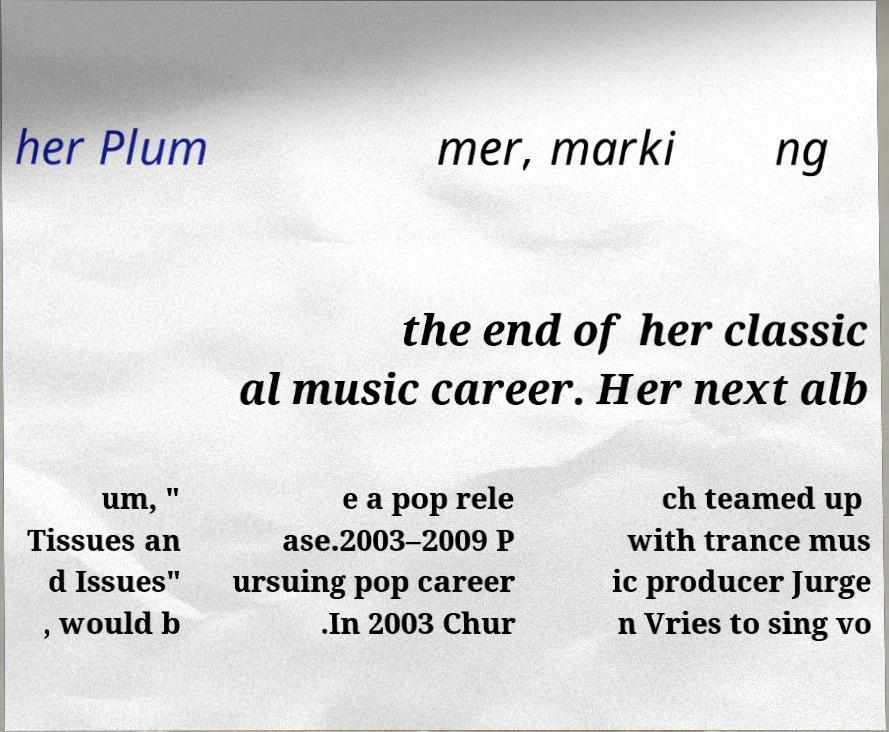Could you extract and type out the text from this image? her Plum mer, marki ng the end of her classic al music career. Her next alb um, " Tissues an d Issues" , would b e a pop rele ase.2003–2009 P ursuing pop career .In 2003 Chur ch teamed up with trance mus ic producer Jurge n Vries to sing vo 